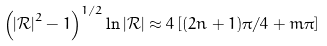<formula> <loc_0><loc_0><loc_500><loc_500>\left ( \left | \mathcal { R } \right | ^ { 2 } - 1 \right ) ^ { 1 / 2 } \ln \left | \mathcal { R } \right | \approx 4 \left [ ( 2 n + 1 ) \pi / 4 + m \pi \right ]</formula> 